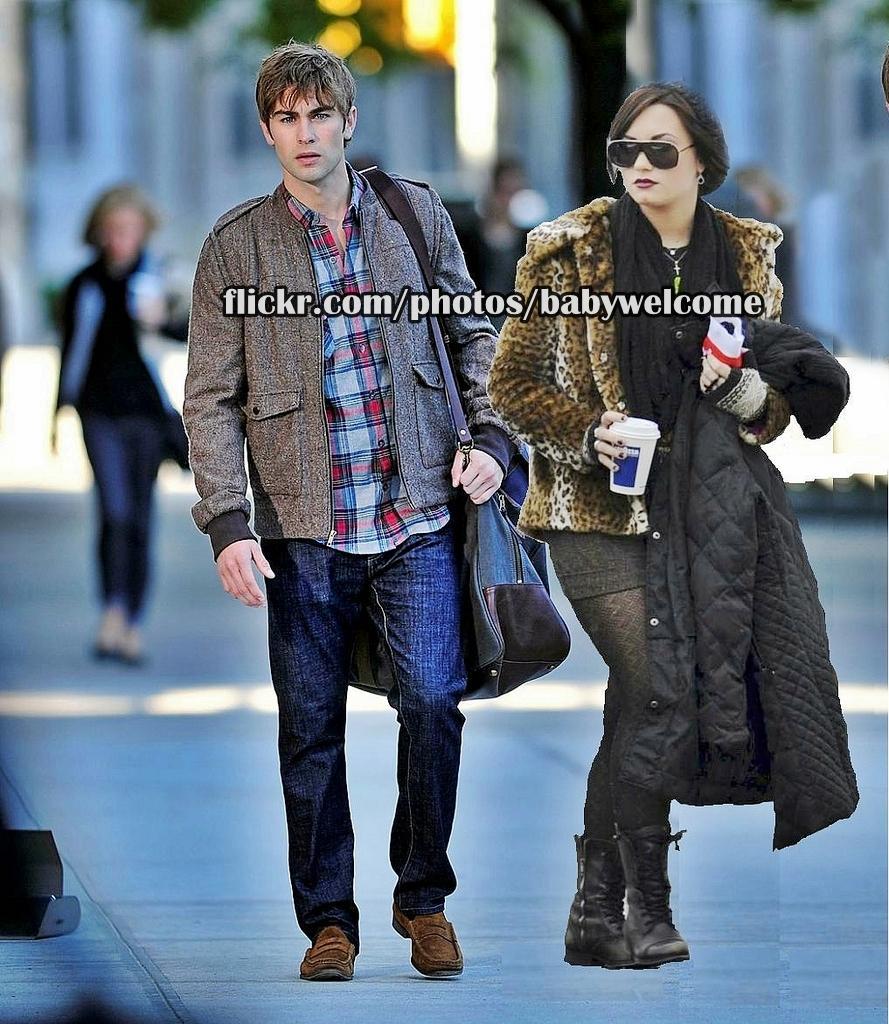Please provide a concise description of this image. The image is taken from some website there are two people walking together, the second picture is an edited picture, the background of the people is blur. 